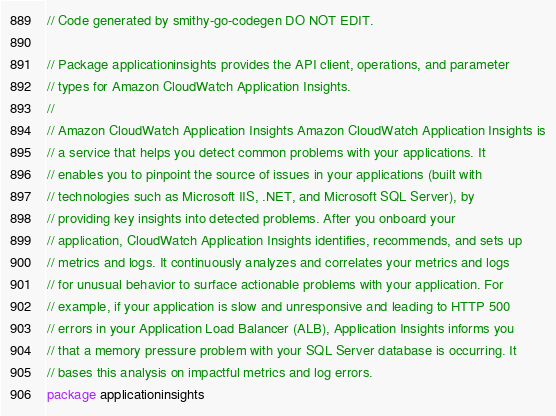<code> <loc_0><loc_0><loc_500><loc_500><_Go_>// Code generated by smithy-go-codegen DO NOT EDIT.

// Package applicationinsights provides the API client, operations, and parameter
// types for Amazon CloudWatch Application Insights.
//
// Amazon CloudWatch Application Insights Amazon CloudWatch Application Insights is
// a service that helps you detect common problems with your applications. It
// enables you to pinpoint the source of issues in your applications (built with
// technologies such as Microsoft IIS, .NET, and Microsoft SQL Server), by
// providing key insights into detected problems. After you onboard your
// application, CloudWatch Application Insights identifies, recommends, and sets up
// metrics and logs. It continuously analyzes and correlates your metrics and logs
// for unusual behavior to surface actionable problems with your application. For
// example, if your application is slow and unresponsive and leading to HTTP 500
// errors in your Application Load Balancer (ALB), Application Insights informs you
// that a memory pressure problem with your SQL Server database is occurring. It
// bases this analysis on impactful metrics and log errors.
package applicationinsights
</code> 